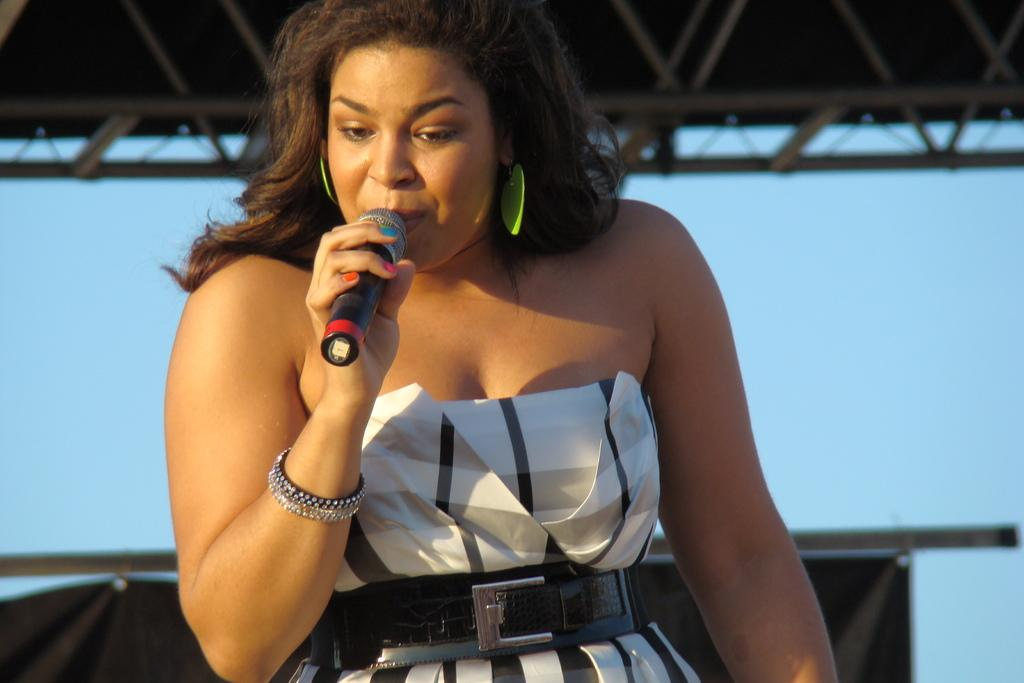Who is the main subject in the image? There is a woman in the image. What is the woman doing in the image? The woman is singing on a mic. What can be seen in the background of the image? There is a sky visible in the background of the image. What is the wealth of the committee in the image? There is no committee present in the image, and therefore no wealth can be attributed to it. 